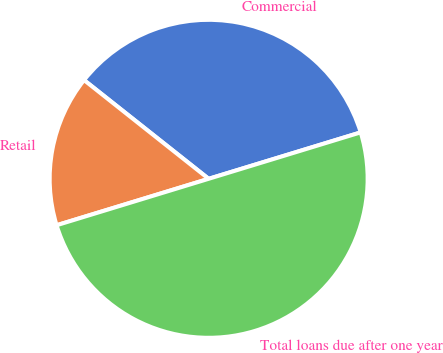Convert chart. <chart><loc_0><loc_0><loc_500><loc_500><pie_chart><fcel>Commercial<fcel>Retail<fcel>Total loans due after one year<nl><fcel>34.62%<fcel>15.38%<fcel>50.0%<nl></chart> 